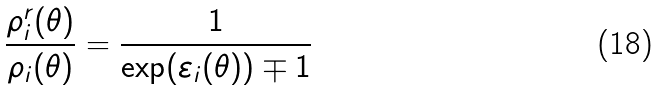Convert formula to latex. <formula><loc_0><loc_0><loc_500><loc_500>\frac { \rho _ { i } ^ { r } ( \theta ) } { \rho _ { i } ( \theta ) } = \frac { 1 } { \exp ( \varepsilon _ { i } ( \theta ) ) \mp 1 }</formula> 